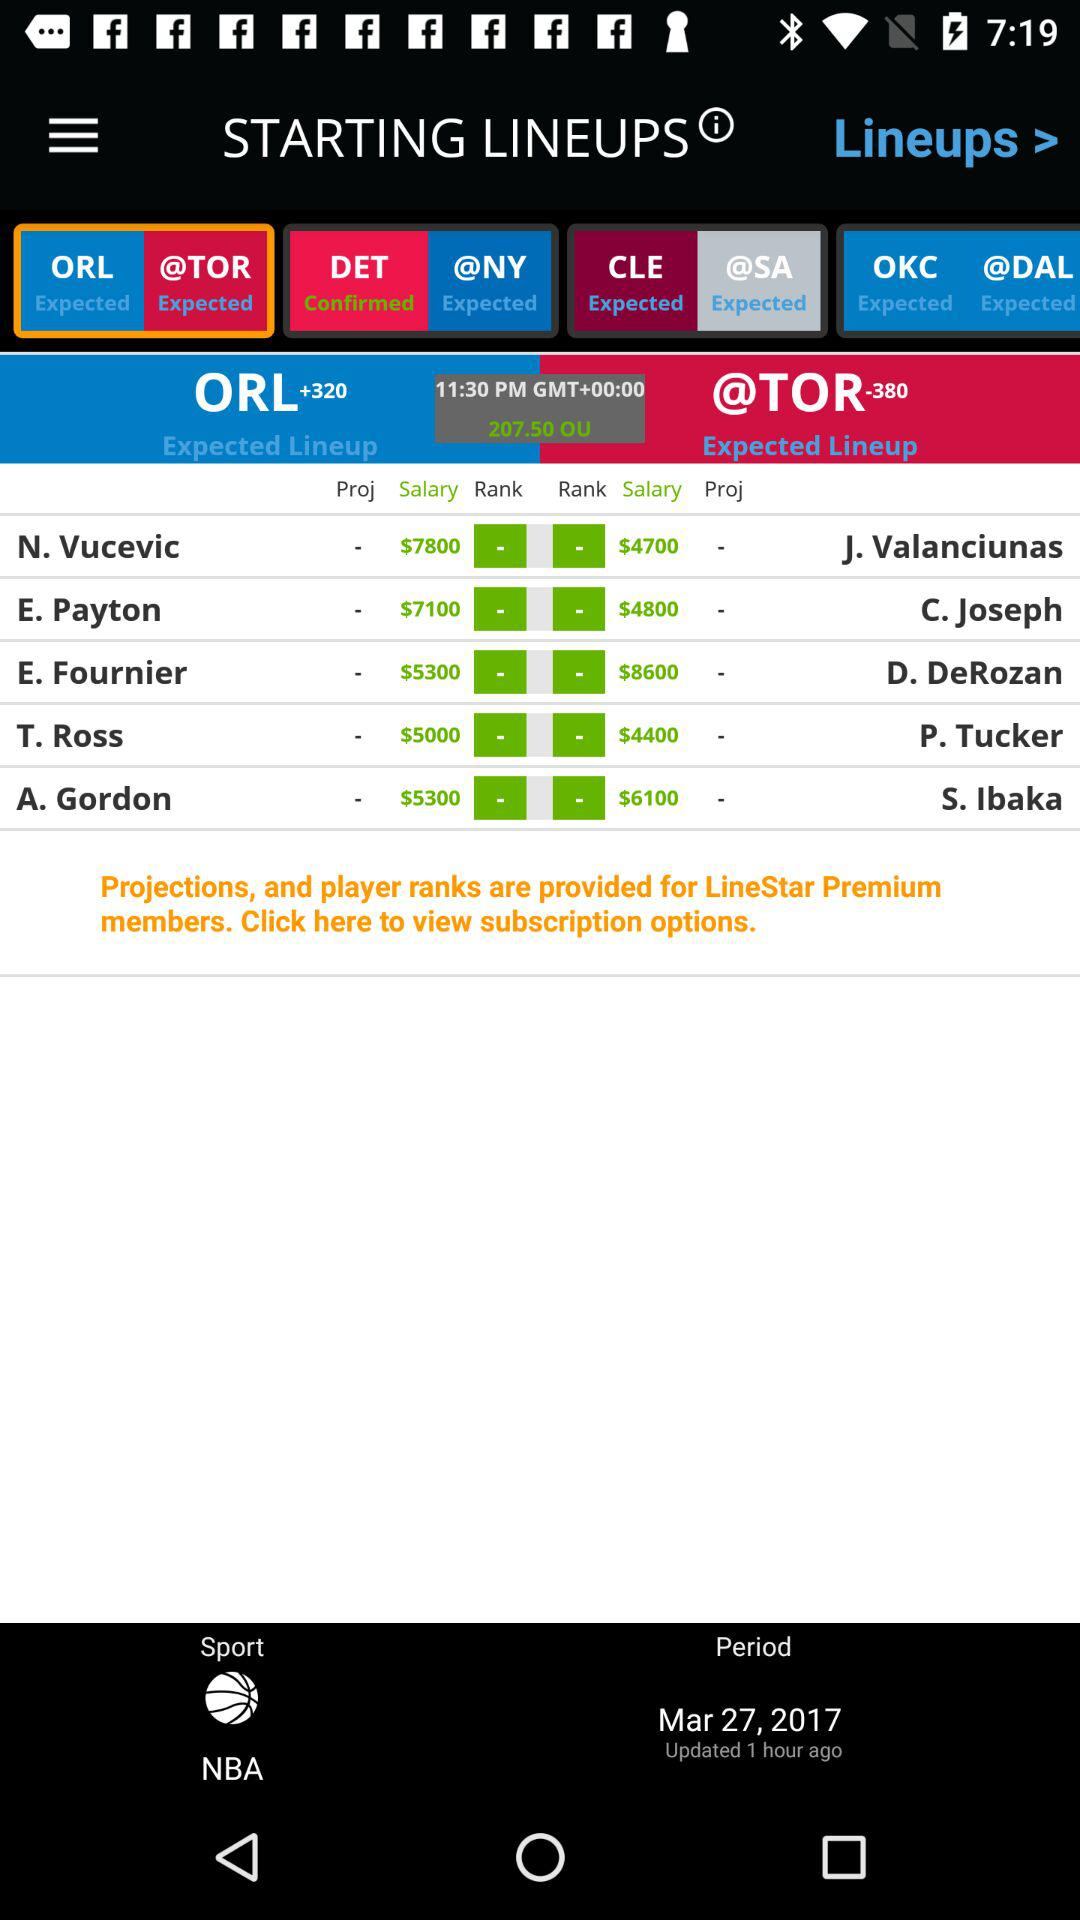What is the rank of T. Ross?
When the provided information is insufficient, respond with <no answer>. <no answer> 